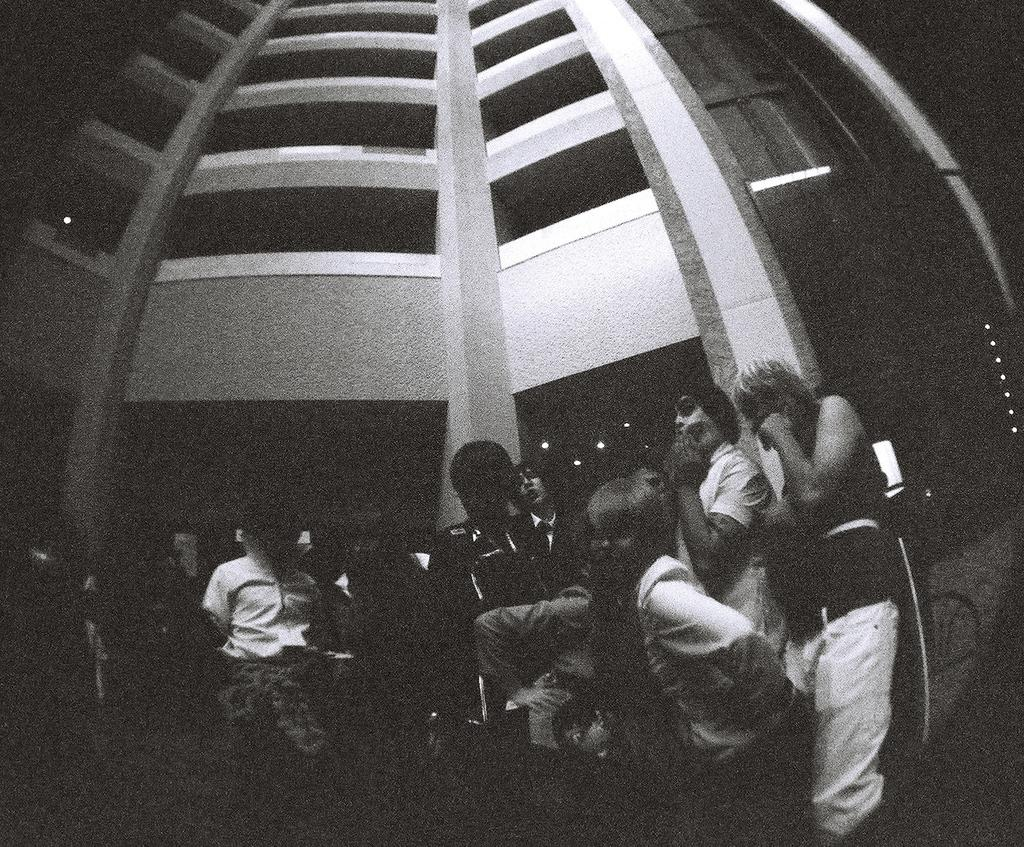What is the color scheme of the image? The image is black and white. What type of structure can be seen in the image? There is a building in the image. Are there any living beings present in the image? Yes, there are people in the image. What can be seen illuminating the scene in the image? There are lights visible in the image. What type of cable is being used by the coach in the image? There is no coach or cable present in the image. What is the coach protesting about in the image? There is no protest or coach present in the image. 